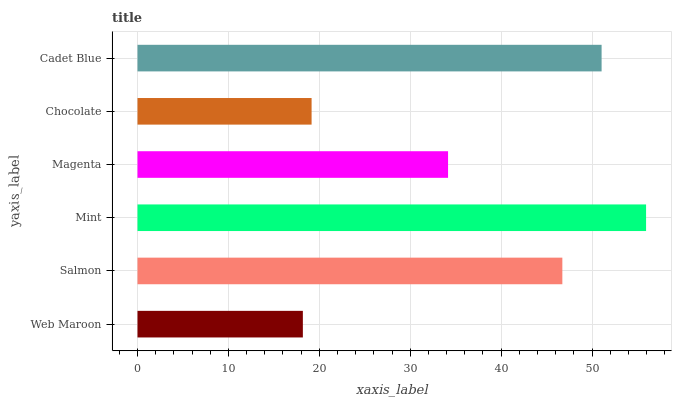Is Web Maroon the minimum?
Answer yes or no. Yes. Is Mint the maximum?
Answer yes or no. Yes. Is Salmon the minimum?
Answer yes or no. No. Is Salmon the maximum?
Answer yes or no. No. Is Salmon greater than Web Maroon?
Answer yes or no. Yes. Is Web Maroon less than Salmon?
Answer yes or no. Yes. Is Web Maroon greater than Salmon?
Answer yes or no. No. Is Salmon less than Web Maroon?
Answer yes or no. No. Is Salmon the high median?
Answer yes or no. Yes. Is Magenta the low median?
Answer yes or no. Yes. Is Cadet Blue the high median?
Answer yes or no. No. Is Chocolate the low median?
Answer yes or no. No. 